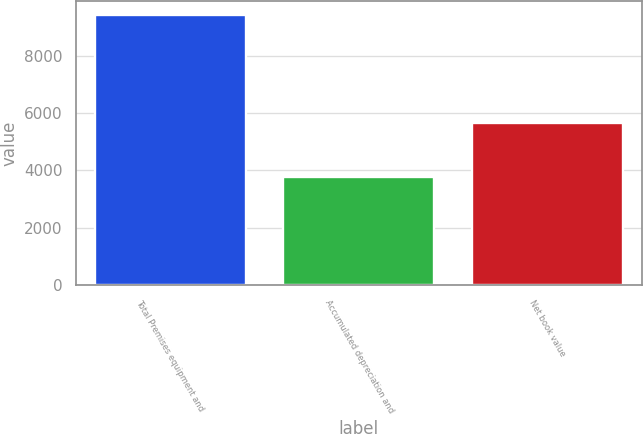Convert chart to OTSL. <chart><loc_0><loc_0><loc_500><loc_500><bar_chart><fcel>Total Premises equipment and<fcel>Accumulated depreciation and<fcel>Net book value<nl><fcel>9416<fcel>3773<fcel>5643<nl></chart> 